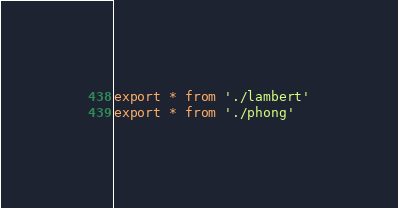<code> <loc_0><loc_0><loc_500><loc_500><_JavaScript_>export * from './lambert'
export * from './phong'
</code> 